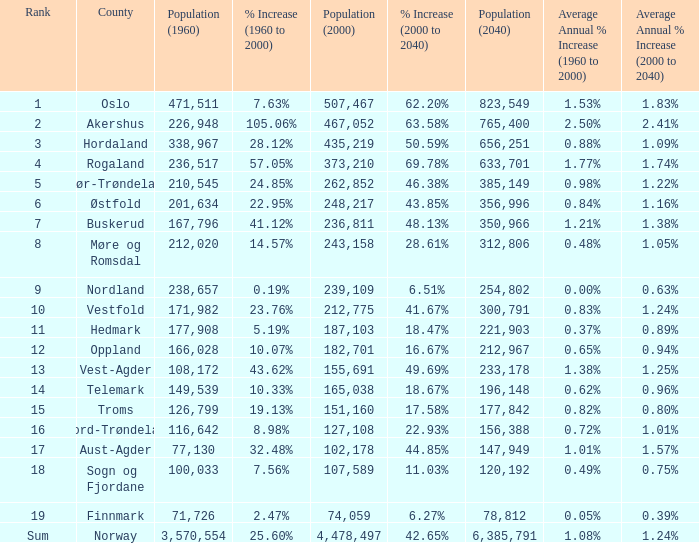What was the population of a county in 1960 that had a population of 467,052 in 2000 and 78,812 in 2040? None. 